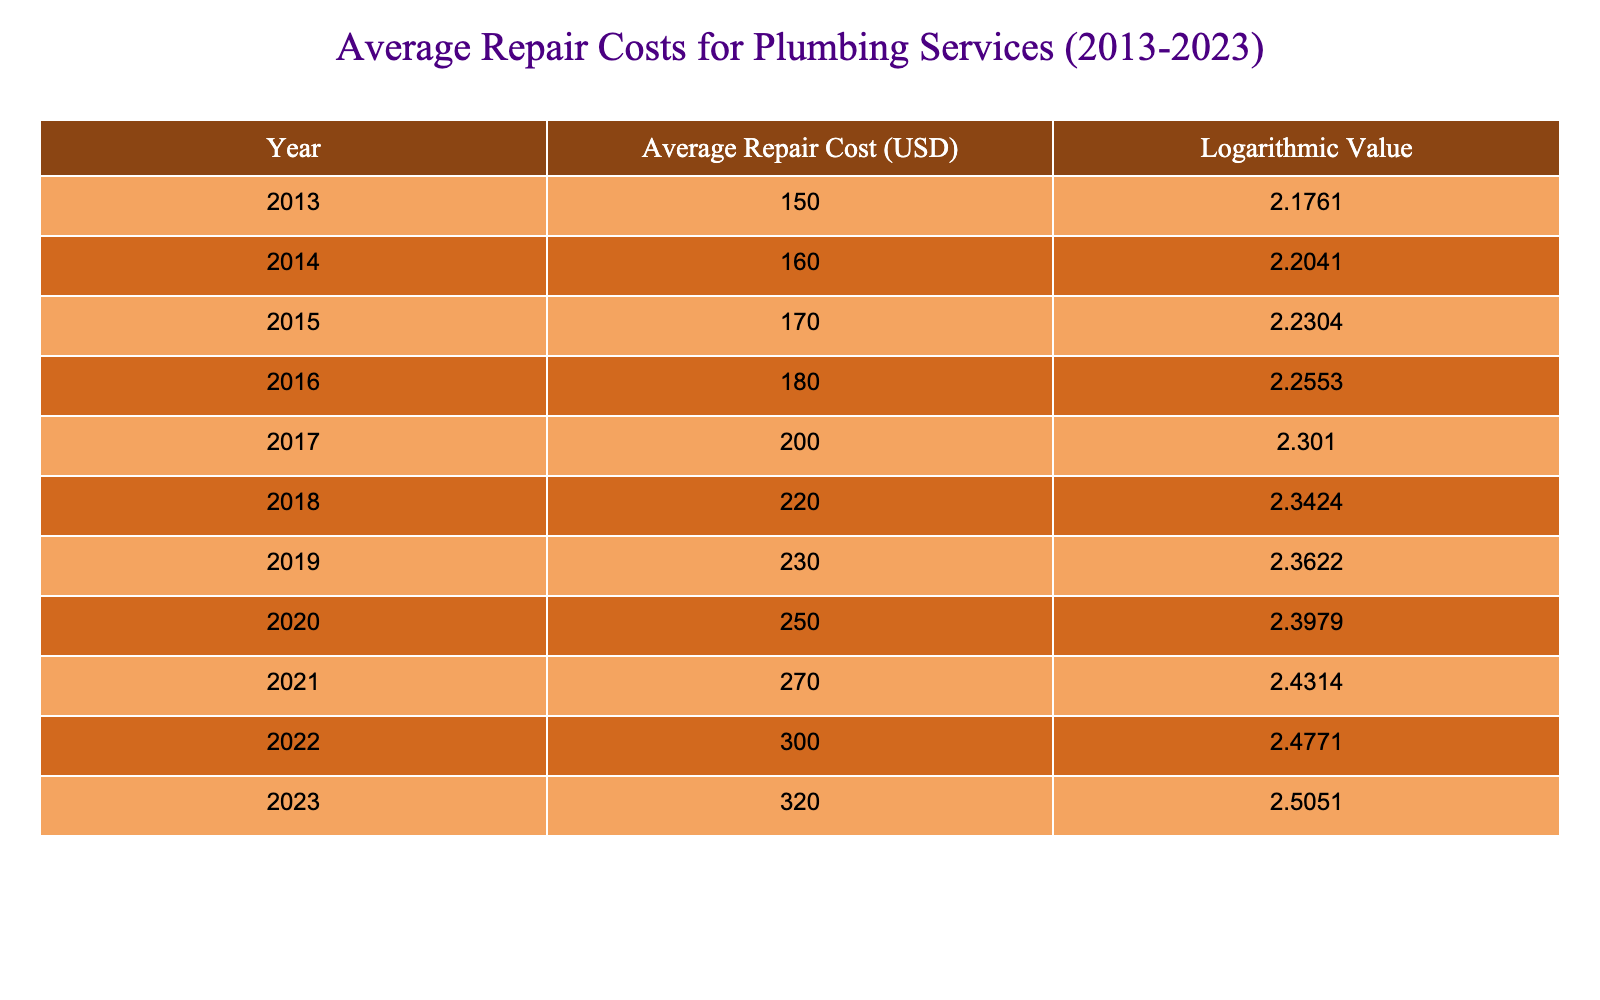What was the average repair cost in 2015? Looking at the table, I can see that the average repair cost for the year 2015 is listed directly in the second column. It shows 170 USD.
Answer: 170 USD What year saw an average repair cost of 250 USD? To answer this, I look for the row in the table where the average repair cost equals 250 USD. That is found in the year 2020.
Answer: 2020 Was the average repair cost higher in 2019 than in 2016? I need to compare the average repair costs for the years 2019 and 2016. The table shows that in 2019 the cost is 230 USD, and in 2016 it is 180 USD. Since 230 is greater than 180, the statement is true.
Answer: Yes What is the increase in average repair cost from 2013 to 2023? To find this increase, I first look at the average repair cost for 2013, which is 150 USD, and for 2023, which is 320 USD. Then, I calculate the difference: 320 - 150 = 170 USD.
Answer: 170 USD In which year did the average repair cost first exceed 200 USD? I check the years listed in the table to find the first instance where the average repair cost surpasses 200 USD. That occurs in 2017, where the cost reached 200 USD.
Answer: 2017 What is the average of the average repair costs from 2013 to 2022? To calculate this average, I first sum the average repair costs from 2013 to 2022, which are: 150, 160, 170, 180, 200, 220, 230, 250, 270, and 300. The sum totals 1,730 USD. Next, I divide this by the number of years (10), giving 1,730 / 10 = 173 USD.
Answer: 173 USD Did more years see an average repair cost above 200 USD or below? I count the number of years with costs above 200 USD: 2017, 2018, 2019, 2020, 2021, 2022, and 2023 (7 years). For those below 200 USD, I look at 2013, 2014, 2015, and 2016, totaling 4 years. Since 7 is greater than 4, the result is confirmed.
Answer: Above 200 USD What was the logarithmic value associated with the average repair cost in 2021? Referring to the table, I find the row for 2021, which has an associated logarithmic value of 2.4314.
Answer: 2.4314 